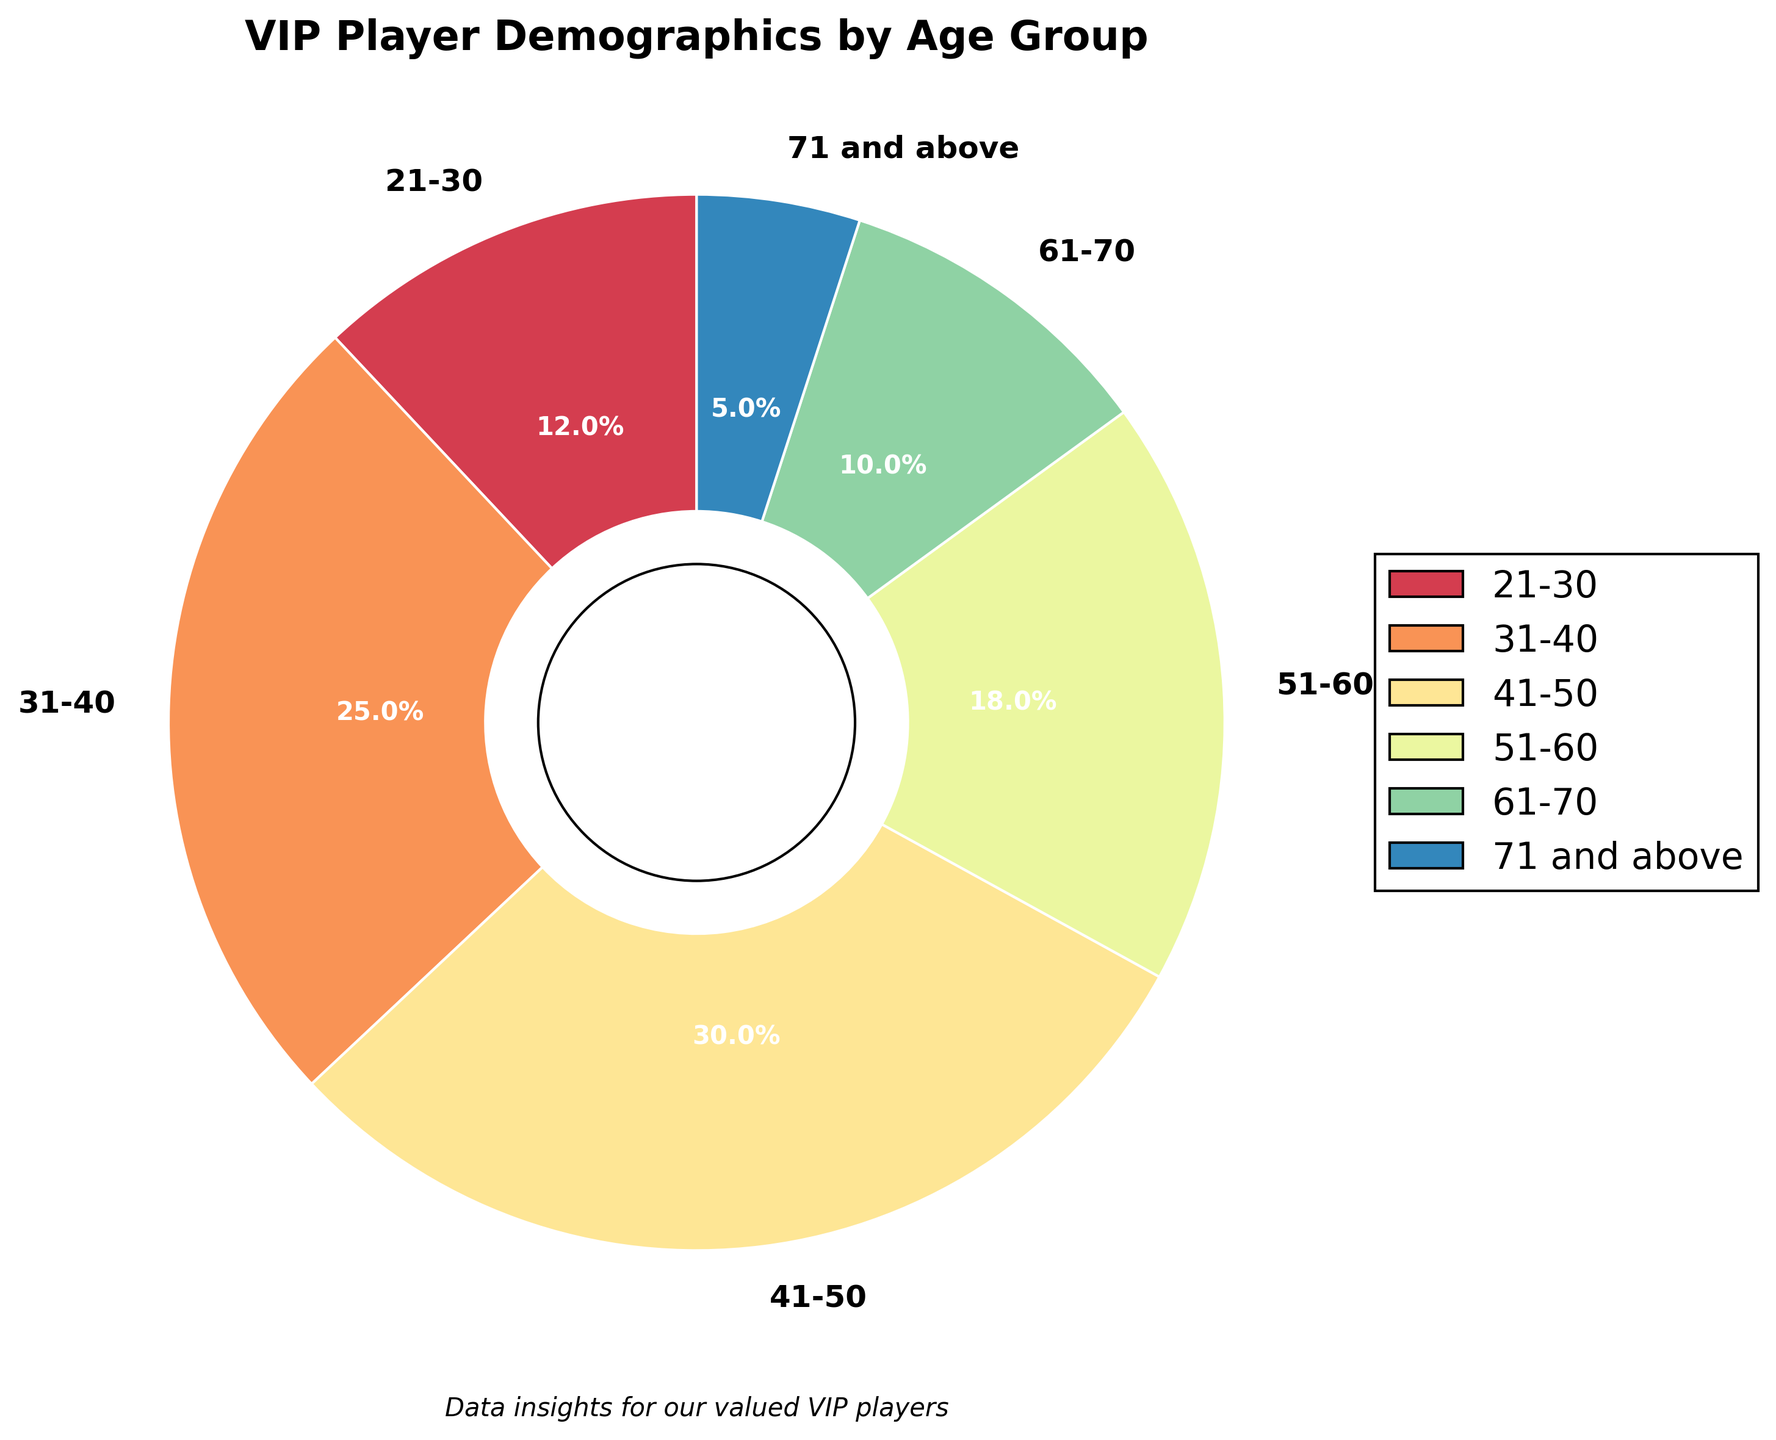What age group has the largest percentage of VIP players? The age group with the largest percentage will have the biggest wedge in the pie chart. By looking at the chart, the 41-50 age group has the largest segment.
Answer: 41-50 What is the combined percentage of VIP players aged 31-40 and 51-60? To find the combined percentage, add the percentages of the 31-40 age group (25%) and the 51-60 age group (18%). 25 + 18 = 43.
Answer: 43% Which age group has fewer players, 21-30 or 61-70? Compare the percentages of the 21-30 age group (12%) and the 61-70 age group (10%). 10% is less than 12%.
Answer: 61-70 What's the difference in percentage between the 41-50 age group and the 71 and above age group? Subtract the percentage of the 71 and above age group (5%) from the 41-50 age group (30%). 30 - 5 = 25.
Answer: 25% What are the colors used for the 51-60 and 71 and above age groups? Identify the colors used in the pie chart for the specified age groups. The 51-60 age group is typically represented by a specific slice color, as is the 71 and above group.
Answer: Specific colors according to the chart (identify on viewing) How does the percentage of VIP players aged 31-40 compare to those aged 21-30? Compare the percentages of the 31-40 age group (25%) and the 21-30 age group (12%). 25% is greater than 12%.
Answer: 31-40 is greater What is the combined total percentage of VIP players aged over 50? Add the percentages of the 51-60 age group (18%), the 61-70 age group (10%), and the 71 and above age group (5%). 18 + 10 + 5 = 33.
Answer: 33% Which age group has the smallest percentage of VIP players? The smallest segment in the pie chart corresponds to the age group with the least percentage. This is the 71 and above age group.
Answer: 71 and above What is the average percentage of VIP players in all age groups? Add all the percentages together and divide by the number of age groups (6). (12 + 25 + 30 + 18 + 10 + 5) / 6 = 16.67.
Answer: 16.67% How does the percentage of the 21-30 age group compare to the combined percentage of the 61-70 and 71 and above age groups? Add the percentages of the 61-70 (10%) and 71 and above (5%) groups, then compare with the 21-30 age group's percentage. 10 + 5 = 15%; 12% (21-30) is less than 15%.
Answer: 21-30 is less 